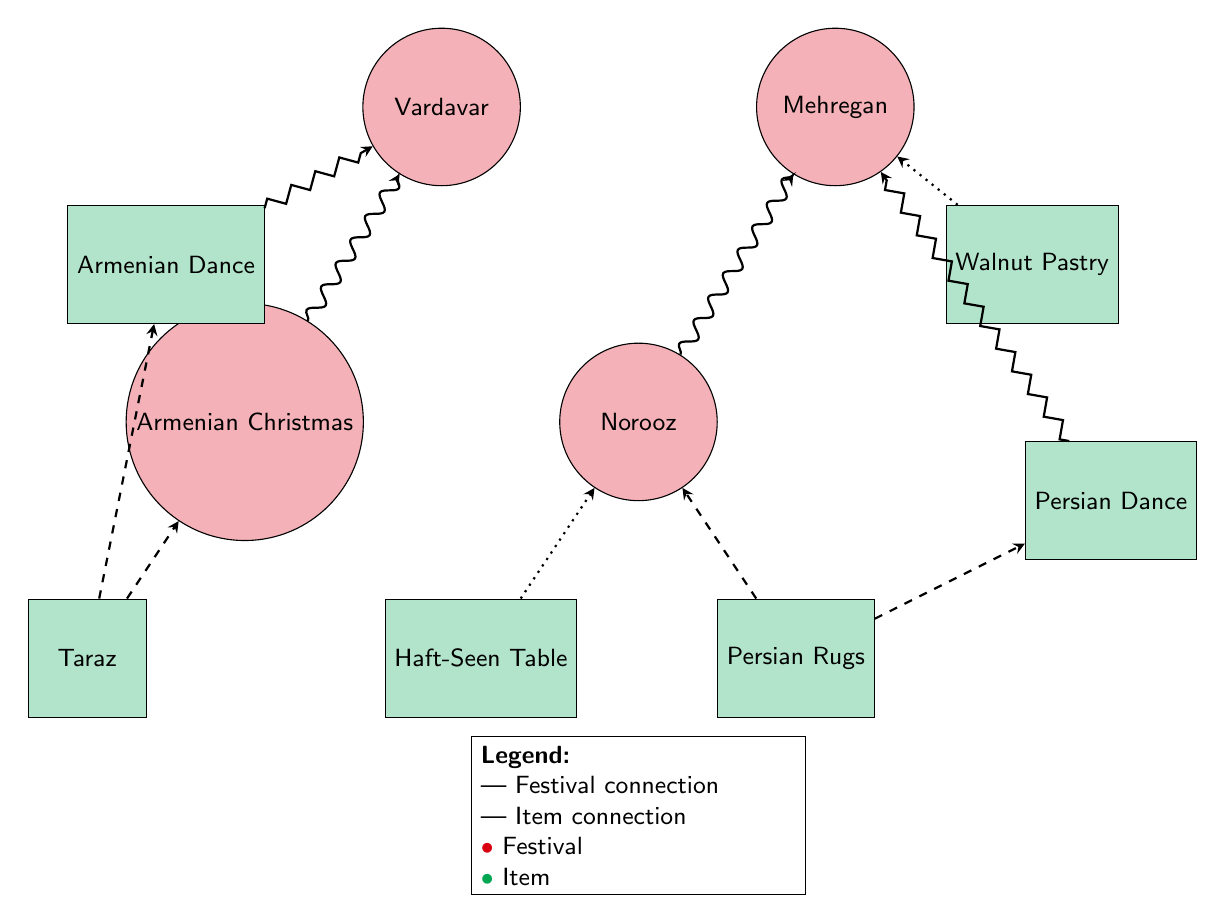What festivals are connected to Armenian Christmas? The diagram shows that Armenian Christmas is connected to two festivals: Vardavar (solid line) and Taraz (dashed line). Therefore, the answer is based on the relationships from the node of Armenian Christmas.
Answer: Vardavar, Taraz How many items are linked to Norooz? Observing the connections from the Norooz festival node, it is linked to three items: Persian Rugs, Haft-Seen Table, and Mehregan (as an additional festival connection). Thus, counting these links, we see that there are 3 total connected items.
Answer: 3 Which item is linked to Vardavar? The diagram indicates that Vardavar is directly connected to one item, Armenian Dance (via a zigzag line). Therefore, we look specifically at the connections to find the answer directly relating to Vardavar.
Answer: Armenian Dance What is the connection type between Walnut Pastry and Mehregan? The connection from Walnut Pastry to Mehregan is represented by a dotted line on the diagram, indicating this line signifies the relationship is a connection to an item. Hence, we determine the relationship type based on the style of the connecting line.
Answer: item connection Which festival is linked to Persian Dance? Analyzing the diagram, the Persian Dance is connected solely to Mehregan through a dashed connection line. Therefore, we check the connections from the Persian Dance to find it linked to only one festival.
Answer: Mehregan How many total nodes are in the diagram? By counting the nodes listed in the diagram, we see there are ten nodes total—four festival nodes and six item nodes. Hence, the answer is a simple addition of these categories.
Answer: 10 Which item is linked to both Taraz and Armenian Dance? The diagram shows Taraz is connected to Armenian Dance via a dashed line, indicating an item connection. Therefore, to find the item that connects both, we observe the connections leading specifically to those two.
Answer: Taraz What type of connection does Haft-Seen Table have with Norooz? Upon inspecting the connection from Haft-Seen Table to Norooz, it is a dotted line, which denotes this as an item connection. Upon confirming this type visually on the diagram, the answer reflects the connection type accurately.
Answer: item connection What is the common link between Persian Rugs and Norooz? The diagram reveals that Persian Rugs connects to Norooz directly, and it is represented by a solid line. Thus, assessing the relationship types here, we can conclude the nature of the link.
Answer: Norooz 